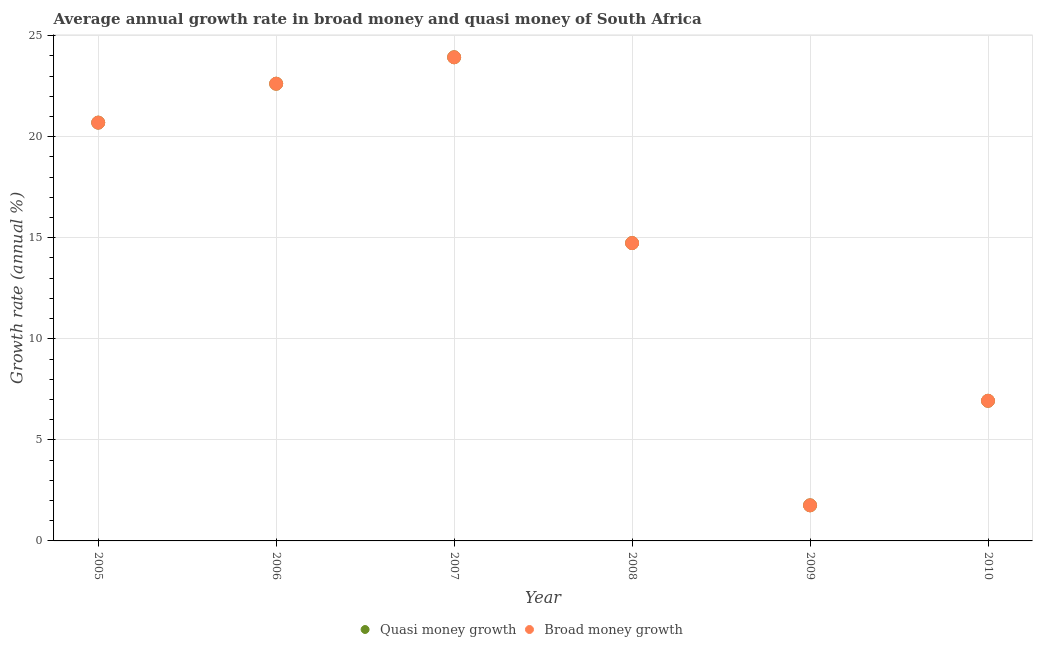What is the annual growth rate in quasi money in 2005?
Keep it short and to the point. 20.7. Across all years, what is the maximum annual growth rate in broad money?
Your answer should be very brief. 23.93. Across all years, what is the minimum annual growth rate in broad money?
Provide a succinct answer. 1.76. In which year was the annual growth rate in broad money maximum?
Your answer should be very brief. 2007. What is the total annual growth rate in quasi money in the graph?
Give a very brief answer. 90.68. What is the difference between the annual growth rate in broad money in 2005 and that in 2006?
Your answer should be very brief. -1.93. What is the difference between the annual growth rate in quasi money in 2007 and the annual growth rate in broad money in 2005?
Provide a short and direct response. 3.23. What is the average annual growth rate in broad money per year?
Offer a terse response. 15.11. In how many years, is the annual growth rate in quasi money greater than 11 %?
Ensure brevity in your answer.  4. What is the ratio of the annual growth rate in quasi money in 2008 to that in 2010?
Provide a succinct answer. 2.13. What is the difference between the highest and the second highest annual growth rate in quasi money?
Your answer should be very brief. 1.31. What is the difference between the highest and the lowest annual growth rate in quasi money?
Offer a very short reply. 22.17. Is the sum of the annual growth rate in broad money in 2007 and 2010 greater than the maximum annual growth rate in quasi money across all years?
Your answer should be compact. Yes. Does the annual growth rate in quasi money monotonically increase over the years?
Offer a terse response. No. How many dotlines are there?
Offer a very short reply. 2. Are the values on the major ticks of Y-axis written in scientific E-notation?
Give a very brief answer. No. Does the graph contain any zero values?
Provide a succinct answer. No. Where does the legend appear in the graph?
Provide a short and direct response. Bottom center. How are the legend labels stacked?
Give a very brief answer. Horizontal. What is the title of the graph?
Make the answer very short. Average annual growth rate in broad money and quasi money of South Africa. What is the label or title of the X-axis?
Offer a terse response. Year. What is the label or title of the Y-axis?
Offer a terse response. Growth rate (annual %). What is the Growth rate (annual %) in Quasi money growth in 2005?
Your response must be concise. 20.7. What is the Growth rate (annual %) of Broad money growth in 2005?
Keep it short and to the point. 20.7. What is the Growth rate (annual %) of Quasi money growth in 2006?
Offer a very short reply. 22.62. What is the Growth rate (annual %) in Broad money growth in 2006?
Your response must be concise. 22.62. What is the Growth rate (annual %) in Quasi money growth in 2007?
Make the answer very short. 23.93. What is the Growth rate (annual %) of Broad money growth in 2007?
Provide a succinct answer. 23.93. What is the Growth rate (annual %) in Quasi money growth in 2008?
Your answer should be very brief. 14.74. What is the Growth rate (annual %) of Broad money growth in 2008?
Offer a very short reply. 14.74. What is the Growth rate (annual %) in Quasi money growth in 2009?
Provide a succinct answer. 1.76. What is the Growth rate (annual %) in Broad money growth in 2009?
Provide a short and direct response. 1.76. What is the Growth rate (annual %) of Quasi money growth in 2010?
Provide a succinct answer. 6.93. What is the Growth rate (annual %) in Broad money growth in 2010?
Your response must be concise. 6.93. Across all years, what is the maximum Growth rate (annual %) of Quasi money growth?
Keep it short and to the point. 23.93. Across all years, what is the maximum Growth rate (annual %) of Broad money growth?
Ensure brevity in your answer.  23.93. Across all years, what is the minimum Growth rate (annual %) in Quasi money growth?
Your response must be concise. 1.76. Across all years, what is the minimum Growth rate (annual %) in Broad money growth?
Provide a short and direct response. 1.76. What is the total Growth rate (annual %) in Quasi money growth in the graph?
Your answer should be very brief. 90.68. What is the total Growth rate (annual %) of Broad money growth in the graph?
Provide a succinct answer. 90.68. What is the difference between the Growth rate (annual %) of Quasi money growth in 2005 and that in 2006?
Offer a terse response. -1.93. What is the difference between the Growth rate (annual %) of Broad money growth in 2005 and that in 2006?
Your response must be concise. -1.93. What is the difference between the Growth rate (annual %) of Quasi money growth in 2005 and that in 2007?
Offer a very short reply. -3.23. What is the difference between the Growth rate (annual %) in Broad money growth in 2005 and that in 2007?
Your answer should be compact. -3.23. What is the difference between the Growth rate (annual %) of Quasi money growth in 2005 and that in 2008?
Provide a short and direct response. 5.96. What is the difference between the Growth rate (annual %) in Broad money growth in 2005 and that in 2008?
Offer a terse response. 5.96. What is the difference between the Growth rate (annual %) of Quasi money growth in 2005 and that in 2009?
Your answer should be compact. 18.94. What is the difference between the Growth rate (annual %) of Broad money growth in 2005 and that in 2009?
Keep it short and to the point. 18.94. What is the difference between the Growth rate (annual %) in Quasi money growth in 2005 and that in 2010?
Keep it short and to the point. 13.76. What is the difference between the Growth rate (annual %) of Broad money growth in 2005 and that in 2010?
Offer a terse response. 13.76. What is the difference between the Growth rate (annual %) in Quasi money growth in 2006 and that in 2007?
Your response must be concise. -1.31. What is the difference between the Growth rate (annual %) of Broad money growth in 2006 and that in 2007?
Your response must be concise. -1.31. What is the difference between the Growth rate (annual %) in Quasi money growth in 2006 and that in 2008?
Keep it short and to the point. 7.88. What is the difference between the Growth rate (annual %) in Broad money growth in 2006 and that in 2008?
Your answer should be very brief. 7.88. What is the difference between the Growth rate (annual %) of Quasi money growth in 2006 and that in 2009?
Your answer should be very brief. 20.86. What is the difference between the Growth rate (annual %) in Broad money growth in 2006 and that in 2009?
Provide a short and direct response. 20.86. What is the difference between the Growth rate (annual %) in Quasi money growth in 2006 and that in 2010?
Offer a terse response. 15.69. What is the difference between the Growth rate (annual %) in Broad money growth in 2006 and that in 2010?
Provide a succinct answer. 15.69. What is the difference between the Growth rate (annual %) in Quasi money growth in 2007 and that in 2008?
Offer a very short reply. 9.19. What is the difference between the Growth rate (annual %) of Broad money growth in 2007 and that in 2008?
Provide a short and direct response. 9.19. What is the difference between the Growth rate (annual %) of Quasi money growth in 2007 and that in 2009?
Give a very brief answer. 22.17. What is the difference between the Growth rate (annual %) of Broad money growth in 2007 and that in 2009?
Make the answer very short. 22.17. What is the difference between the Growth rate (annual %) in Quasi money growth in 2007 and that in 2010?
Ensure brevity in your answer.  17. What is the difference between the Growth rate (annual %) in Broad money growth in 2007 and that in 2010?
Offer a terse response. 17. What is the difference between the Growth rate (annual %) in Quasi money growth in 2008 and that in 2009?
Provide a short and direct response. 12.98. What is the difference between the Growth rate (annual %) of Broad money growth in 2008 and that in 2009?
Your answer should be compact. 12.98. What is the difference between the Growth rate (annual %) of Quasi money growth in 2008 and that in 2010?
Ensure brevity in your answer.  7.8. What is the difference between the Growth rate (annual %) of Broad money growth in 2008 and that in 2010?
Your answer should be very brief. 7.8. What is the difference between the Growth rate (annual %) in Quasi money growth in 2009 and that in 2010?
Provide a short and direct response. -5.17. What is the difference between the Growth rate (annual %) of Broad money growth in 2009 and that in 2010?
Your answer should be compact. -5.17. What is the difference between the Growth rate (annual %) of Quasi money growth in 2005 and the Growth rate (annual %) of Broad money growth in 2006?
Your answer should be very brief. -1.93. What is the difference between the Growth rate (annual %) of Quasi money growth in 2005 and the Growth rate (annual %) of Broad money growth in 2007?
Offer a terse response. -3.23. What is the difference between the Growth rate (annual %) of Quasi money growth in 2005 and the Growth rate (annual %) of Broad money growth in 2008?
Provide a succinct answer. 5.96. What is the difference between the Growth rate (annual %) in Quasi money growth in 2005 and the Growth rate (annual %) in Broad money growth in 2009?
Your answer should be compact. 18.94. What is the difference between the Growth rate (annual %) in Quasi money growth in 2005 and the Growth rate (annual %) in Broad money growth in 2010?
Your answer should be very brief. 13.76. What is the difference between the Growth rate (annual %) in Quasi money growth in 2006 and the Growth rate (annual %) in Broad money growth in 2007?
Offer a terse response. -1.31. What is the difference between the Growth rate (annual %) of Quasi money growth in 2006 and the Growth rate (annual %) of Broad money growth in 2008?
Offer a very short reply. 7.88. What is the difference between the Growth rate (annual %) of Quasi money growth in 2006 and the Growth rate (annual %) of Broad money growth in 2009?
Offer a terse response. 20.86. What is the difference between the Growth rate (annual %) in Quasi money growth in 2006 and the Growth rate (annual %) in Broad money growth in 2010?
Your answer should be very brief. 15.69. What is the difference between the Growth rate (annual %) in Quasi money growth in 2007 and the Growth rate (annual %) in Broad money growth in 2008?
Your answer should be compact. 9.19. What is the difference between the Growth rate (annual %) in Quasi money growth in 2007 and the Growth rate (annual %) in Broad money growth in 2009?
Offer a very short reply. 22.17. What is the difference between the Growth rate (annual %) in Quasi money growth in 2007 and the Growth rate (annual %) in Broad money growth in 2010?
Provide a succinct answer. 17. What is the difference between the Growth rate (annual %) in Quasi money growth in 2008 and the Growth rate (annual %) in Broad money growth in 2009?
Provide a succinct answer. 12.98. What is the difference between the Growth rate (annual %) in Quasi money growth in 2008 and the Growth rate (annual %) in Broad money growth in 2010?
Your response must be concise. 7.8. What is the difference between the Growth rate (annual %) of Quasi money growth in 2009 and the Growth rate (annual %) of Broad money growth in 2010?
Offer a terse response. -5.17. What is the average Growth rate (annual %) in Quasi money growth per year?
Offer a terse response. 15.11. What is the average Growth rate (annual %) of Broad money growth per year?
Offer a very short reply. 15.11. In the year 2005, what is the difference between the Growth rate (annual %) of Quasi money growth and Growth rate (annual %) of Broad money growth?
Give a very brief answer. 0. In the year 2007, what is the difference between the Growth rate (annual %) of Quasi money growth and Growth rate (annual %) of Broad money growth?
Your response must be concise. 0. In the year 2008, what is the difference between the Growth rate (annual %) of Quasi money growth and Growth rate (annual %) of Broad money growth?
Provide a short and direct response. 0. In the year 2010, what is the difference between the Growth rate (annual %) in Quasi money growth and Growth rate (annual %) in Broad money growth?
Provide a short and direct response. 0. What is the ratio of the Growth rate (annual %) of Quasi money growth in 2005 to that in 2006?
Your answer should be very brief. 0.91. What is the ratio of the Growth rate (annual %) of Broad money growth in 2005 to that in 2006?
Your response must be concise. 0.91. What is the ratio of the Growth rate (annual %) in Quasi money growth in 2005 to that in 2007?
Offer a very short reply. 0.86. What is the ratio of the Growth rate (annual %) in Broad money growth in 2005 to that in 2007?
Offer a terse response. 0.86. What is the ratio of the Growth rate (annual %) of Quasi money growth in 2005 to that in 2008?
Offer a very short reply. 1.4. What is the ratio of the Growth rate (annual %) in Broad money growth in 2005 to that in 2008?
Provide a succinct answer. 1.4. What is the ratio of the Growth rate (annual %) in Quasi money growth in 2005 to that in 2009?
Provide a succinct answer. 11.75. What is the ratio of the Growth rate (annual %) of Broad money growth in 2005 to that in 2009?
Your answer should be very brief. 11.75. What is the ratio of the Growth rate (annual %) of Quasi money growth in 2005 to that in 2010?
Give a very brief answer. 2.98. What is the ratio of the Growth rate (annual %) of Broad money growth in 2005 to that in 2010?
Provide a succinct answer. 2.98. What is the ratio of the Growth rate (annual %) of Quasi money growth in 2006 to that in 2007?
Offer a very short reply. 0.95. What is the ratio of the Growth rate (annual %) of Broad money growth in 2006 to that in 2007?
Ensure brevity in your answer.  0.95. What is the ratio of the Growth rate (annual %) of Quasi money growth in 2006 to that in 2008?
Your response must be concise. 1.53. What is the ratio of the Growth rate (annual %) of Broad money growth in 2006 to that in 2008?
Make the answer very short. 1.53. What is the ratio of the Growth rate (annual %) in Quasi money growth in 2006 to that in 2009?
Provide a short and direct response. 12.85. What is the ratio of the Growth rate (annual %) of Broad money growth in 2006 to that in 2009?
Offer a very short reply. 12.85. What is the ratio of the Growth rate (annual %) in Quasi money growth in 2006 to that in 2010?
Ensure brevity in your answer.  3.26. What is the ratio of the Growth rate (annual %) in Broad money growth in 2006 to that in 2010?
Give a very brief answer. 3.26. What is the ratio of the Growth rate (annual %) in Quasi money growth in 2007 to that in 2008?
Your answer should be very brief. 1.62. What is the ratio of the Growth rate (annual %) in Broad money growth in 2007 to that in 2008?
Give a very brief answer. 1.62. What is the ratio of the Growth rate (annual %) of Quasi money growth in 2007 to that in 2009?
Make the answer very short. 13.59. What is the ratio of the Growth rate (annual %) of Broad money growth in 2007 to that in 2009?
Your answer should be very brief. 13.59. What is the ratio of the Growth rate (annual %) in Quasi money growth in 2007 to that in 2010?
Your response must be concise. 3.45. What is the ratio of the Growth rate (annual %) in Broad money growth in 2007 to that in 2010?
Give a very brief answer. 3.45. What is the ratio of the Growth rate (annual %) in Quasi money growth in 2008 to that in 2009?
Keep it short and to the point. 8.37. What is the ratio of the Growth rate (annual %) of Broad money growth in 2008 to that in 2009?
Provide a succinct answer. 8.37. What is the ratio of the Growth rate (annual %) in Quasi money growth in 2008 to that in 2010?
Give a very brief answer. 2.13. What is the ratio of the Growth rate (annual %) of Broad money growth in 2008 to that in 2010?
Give a very brief answer. 2.13. What is the ratio of the Growth rate (annual %) of Quasi money growth in 2009 to that in 2010?
Keep it short and to the point. 0.25. What is the ratio of the Growth rate (annual %) of Broad money growth in 2009 to that in 2010?
Provide a short and direct response. 0.25. What is the difference between the highest and the second highest Growth rate (annual %) of Quasi money growth?
Your response must be concise. 1.31. What is the difference between the highest and the second highest Growth rate (annual %) in Broad money growth?
Provide a succinct answer. 1.31. What is the difference between the highest and the lowest Growth rate (annual %) in Quasi money growth?
Keep it short and to the point. 22.17. What is the difference between the highest and the lowest Growth rate (annual %) in Broad money growth?
Ensure brevity in your answer.  22.17. 